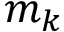Convert formula to latex. <formula><loc_0><loc_0><loc_500><loc_500>m _ { k }</formula> 